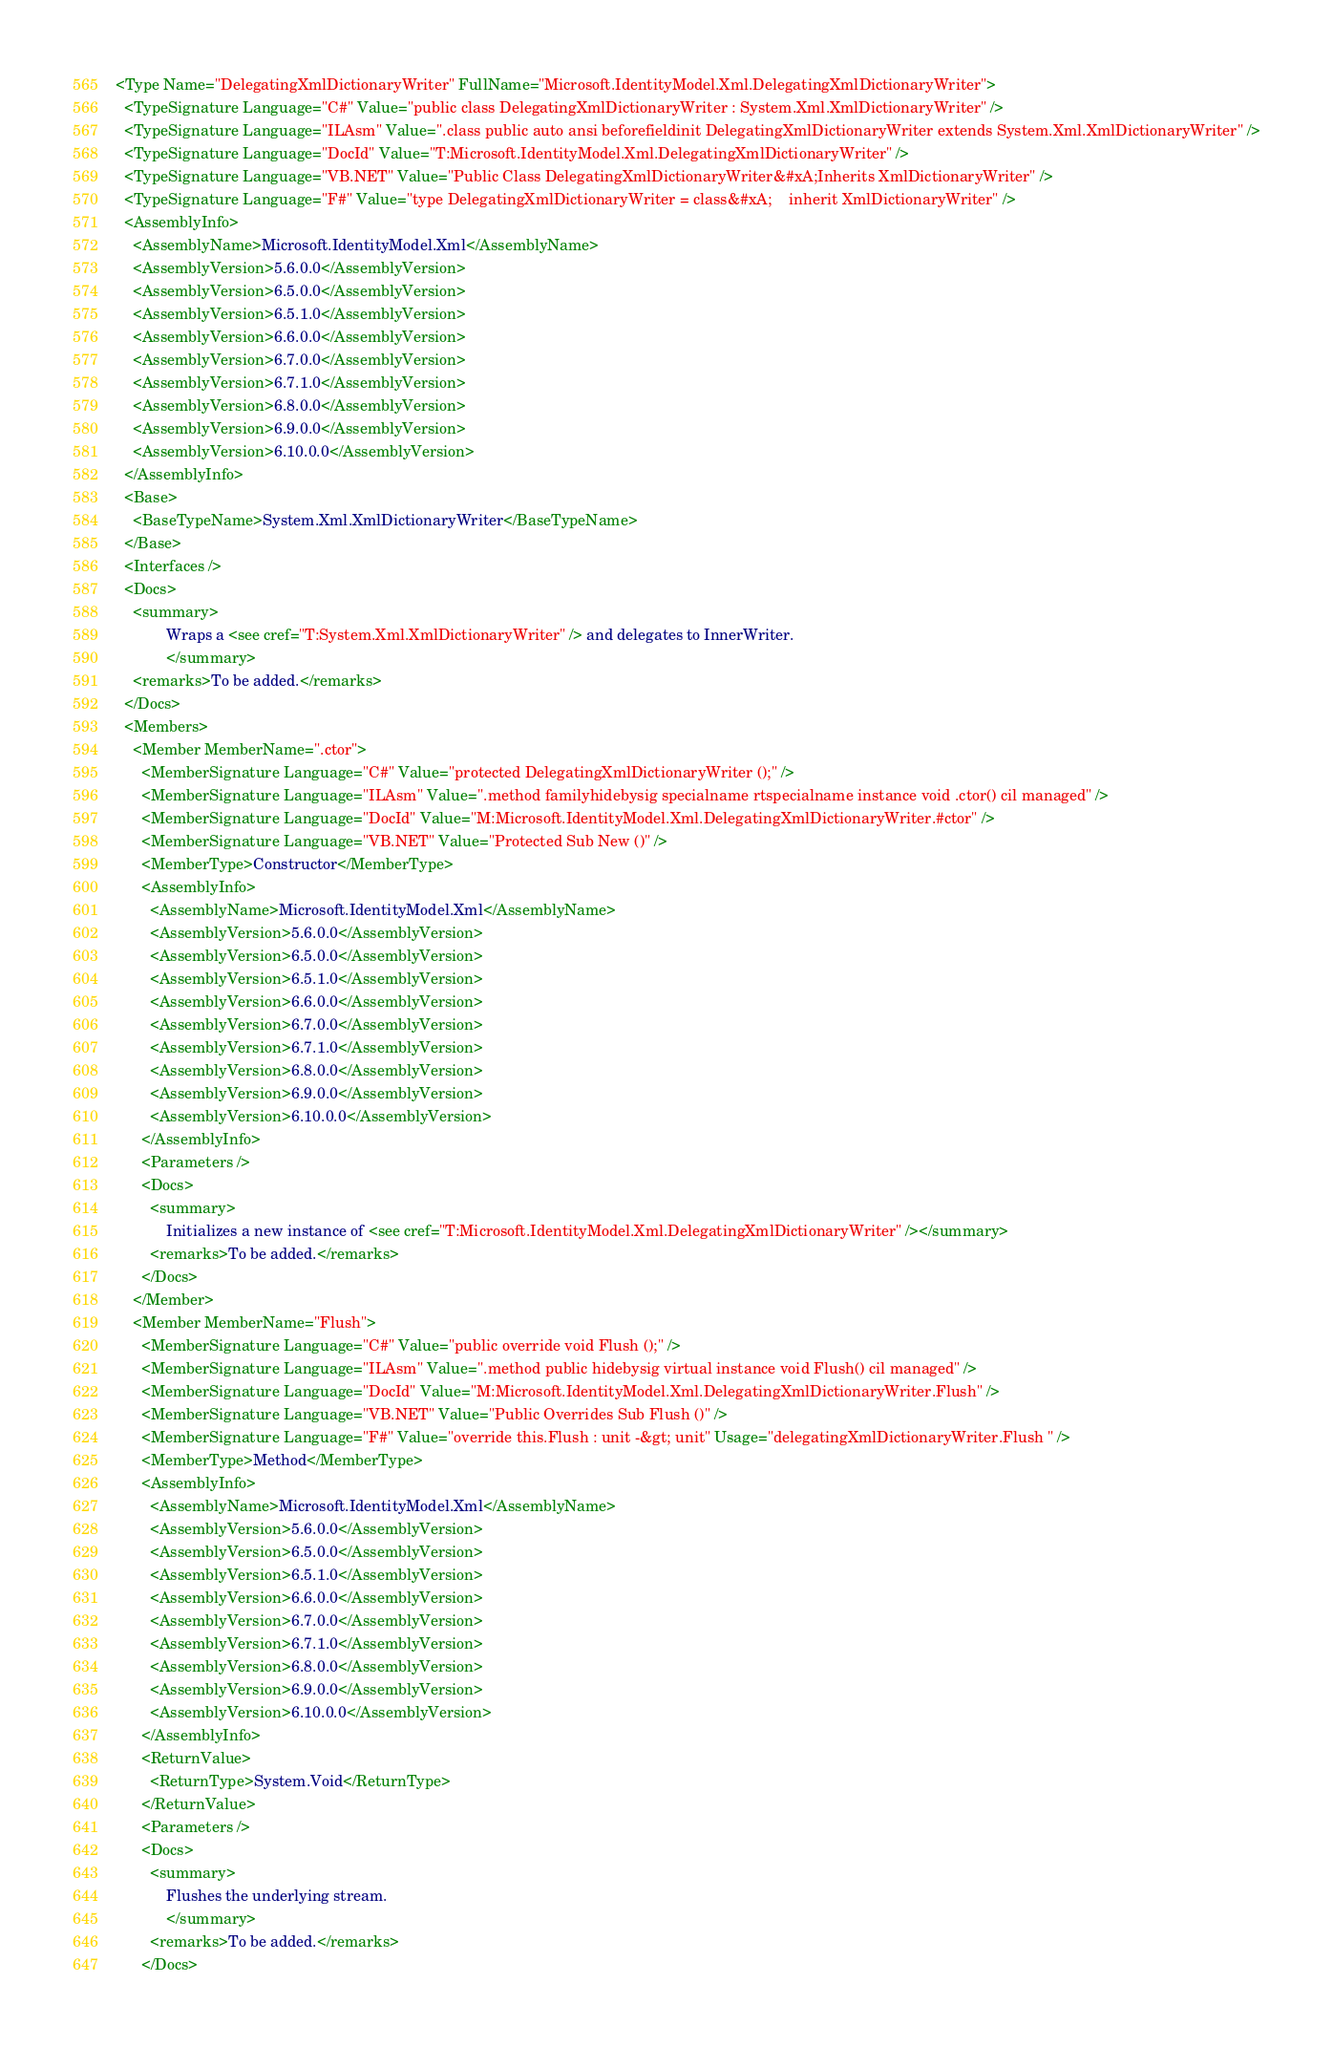Convert code to text. <code><loc_0><loc_0><loc_500><loc_500><_XML_><Type Name="DelegatingXmlDictionaryWriter" FullName="Microsoft.IdentityModel.Xml.DelegatingXmlDictionaryWriter">
  <TypeSignature Language="C#" Value="public class DelegatingXmlDictionaryWriter : System.Xml.XmlDictionaryWriter" />
  <TypeSignature Language="ILAsm" Value=".class public auto ansi beforefieldinit DelegatingXmlDictionaryWriter extends System.Xml.XmlDictionaryWriter" />
  <TypeSignature Language="DocId" Value="T:Microsoft.IdentityModel.Xml.DelegatingXmlDictionaryWriter" />
  <TypeSignature Language="VB.NET" Value="Public Class DelegatingXmlDictionaryWriter&#xA;Inherits XmlDictionaryWriter" />
  <TypeSignature Language="F#" Value="type DelegatingXmlDictionaryWriter = class&#xA;    inherit XmlDictionaryWriter" />
  <AssemblyInfo>
    <AssemblyName>Microsoft.IdentityModel.Xml</AssemblyName>
    <AssemblyVersion>5.6.0.0</AssemblyVersion>
    <AssemblyVersion>6.5.0.0</AssemblyVersion>
    <AssemblyVersion>6.5.1.0</AssemblyVersion>
    <AssemblyVersion>6.6.0.0</AssemblyVersion>
    <AssemblyVersion>6.7.0.0</AssemblyVersion>
    <AssemblyVersion>6.7.1.0</AssemblyVersion>
    <AssemblyVersion>6.8.0.0</AssemblyVersion>
    <AssemblyVersion>6.9.0.0</AssemblyVersion>
    <AssemblyVersion>6.10.0.0</AssemblyVersion>
  </AssemblyInfo>
  <Base>
    <BaseTypeName>System.Xml.XmlDictionaryWriter</BaseTypeName>
  </Base>
  <Interfaces />
  <Docs>
    <summary>
            Wraps a <see cref="T:System.Xml.XmlDictionaryWriter" /> and delegates to InnerWriter.
            </summary>
    <remarks>To be added.</remarks>
  </Docs>
  <Members>
    <Member MemberName=".ctor">
      <MemberSignature Language="C#" Value="protected DelegatingXmlDictionaryWriter ();" />
      <MemberSignature Language="ILAsm" Value=".method familyhidebysig specialname rtspecialname instance void .ctor() cil managed" />
      <MemberSignature Language="DocId" Value="M:Microsoft.IdentityModel.Xml.DelegatingXmlDictionaryWriter.#ctor" />
      <MemberSignature Language="VB.NET" Value="Protected Sub New ()" />
      <MemberType>Constructor</MemberType>
      <AssemblyInfo>
        <AssemblyName>Microsoft.IdentityModel.Xml</AssemblyName>
        <AssemblyVersion>5.6.0.0</AssemblyVersion>
        <AssemblyVersion>6.5.0.0</AssemblyVersion>
        <AssemblyVersion>6.5.1.0</AssemblyVersion>
        <AssemblyVersion>6.6.0.0</AssemblyVersion>
        <AssemblyVersion>6.7.0.0</AssemblyVersion>
        <AssemblyVersion>6.7.1.0</AssemblyVersion>
        <AssemblyVersion>6.8.0.0</AssemblyVersion>
        <AssemblyVersion>6.9.0.0</AssemblyVersion>
        <AssemblyVersion>6.10.0.0</AssemblyVersion>
      </AssemblyInfo>
      <Parameters />
      <Docs>
        <summary>
            Initializes a new instance of <see cref="T:Microsoft.IdentityModel.Xml.DelegatingXmlDictionaryWriter" /></summary>
        <remarks>To be added.</remarks>
      </Docs>
    </Member>
    <Member MemberName="Flush">
      <MemberSignature Language="C#" Value="public override void Flush ();" />
      <MemberSignature Language="ILAsm" Value=".method public hidebysig virtual instance void Flush() cil managed" />
      <MemberSignature Language="DocId" Value="M:Microsoft.IdentityModel.Xml.DelegatingXmlDictionaryWriter.Flush" />
      <MemberSignature Language="VB.NET" Value="Public Overrides Sub Flush ()" />
      <MemberSignature Language="F#" Value="override this.Flush : unit -&gt; unit" Usage="delegatingXmlDictionaryWriter.Flush " />
      <MemberType>Method</MemberType>
      <AssemblyInfo>
        <AssemblyName>Microsoft.IdentityModel.Xml</AssemblyName>
        <AssemblyVersion>5.6.0.0</AssemblyVersion>
        <AssemblyVersion>6.5.0.0</AssemblyVersion>
        <AssemblyVersion>6.5.1.0</AssemblyVersion>
        <AssemblyVersion>6.6.0.0</AssemblyVersion>
        <AssemblyVersion>6.7.0.0</AssemblyVersion>
        <AssemblyVersion>6.7.1.0</AssemblyVersion>
        <AssemblyVersion>6.8.0.0</AssemblyVersion>
        <AssemblyVersion>6.9.0.0</AssemblyVersion>
        <AssemblyVersion>6.10.0.0</AssemblyVersion>
      </AssemblyInfo>
      <ReturnValue>
        <ReturnType>System.Void</ReturnType>
      </ReturnValue>
      <Parameters />
      <Docs>
        <summary>
            Flushes the underlying stream.
            </summary>
        <remarks>To be added.</remarks>
      </Docs></code> 